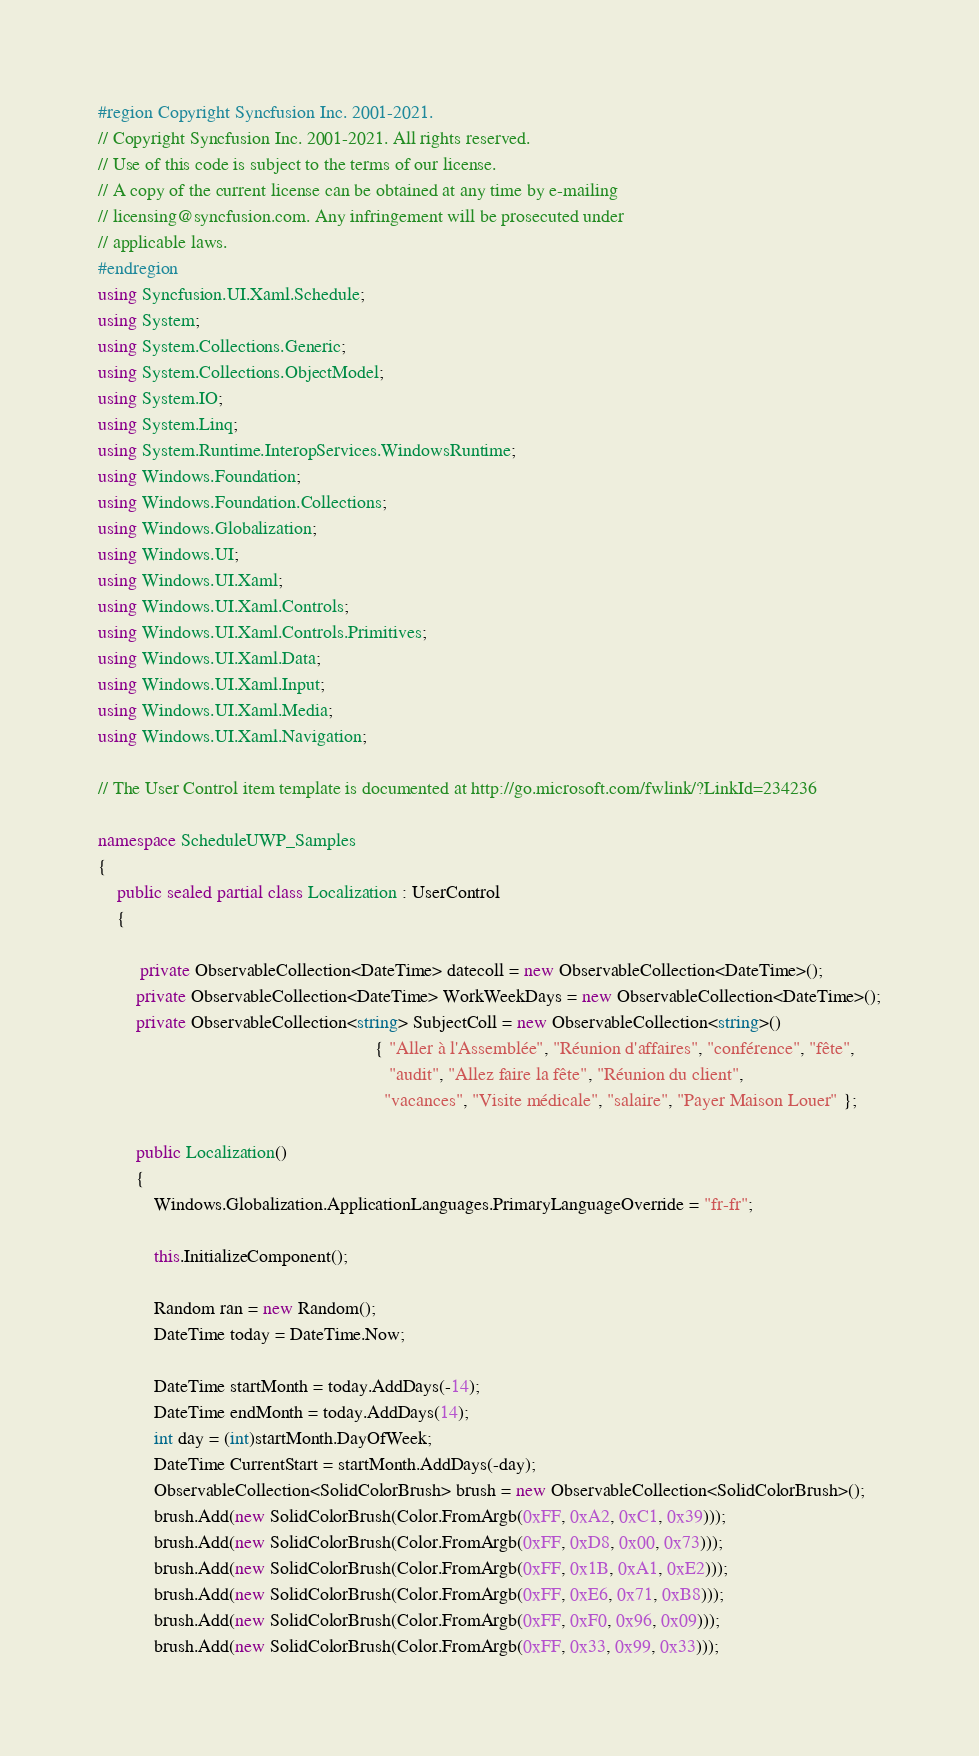<code> <loc_0><loc_0><loc_500><loc_500><_C#_>#region Copyright Syncfusion Inc. 2001-2021.
// Copyright Syncfusion Inc. 2001-2021. All rights reserved.
// Use of this code is subject to the terms of our license.
// A copy of the current license can be obtained at any time by e-mailing
// licensing@syncfusion.com. Any infringement will be prosecuted under
// applicable laws. 
#endregion
using Syncfusion.UI.Xaml.Schedule;
using System;
using System.Collections.Generic;
using System.Collections.ObjectModel;
using System.IO;
using System.Linq;
using System.Runtime.InteropServices.WindowsRuntime;
using Windows.Foundation;
using Windows.Foundation.Collections;
using Windows.Globalization;
using Windows.UI;
using Windows.UI.Xaml;
using Windows.UI.Xaml.Controls;
using Windows.UI.Xaml.Controls.Primitives;
using Windows.UI.Xaml.Data;
using Windows.UI.Xaml.Input;
using Windows.UI.Xaml.Media;
using Windows.UI.Xaml.Navigation;

// The User Control item template is documented at http://go.microsoft.com/fwlink/?LinkId=234236

namespace ScheduleUWP_Samples
{
    public sealed partial class Localization : UserControl
    {
        
         private ObservableCollection<DateTime> datecoll = new ObservableCollection<DateTime>();
        private ObservableCollection<DateTime> WorkWeekDays = new ObservableCollection<DateTime>();
        private ObservableCollection<string> SubjectColl = new ObservableCollection<string>()
                                                           { "Aller à l'Assemblée", "Réunion d'affaires", "conférence", "fête",
                                                              "audit", "Allez faire la fête", "Réunion du client",
                                                             "vacances", "Visite médicale", "salaire", "Payer Maison Louer" };

        public Localization()
        {
            Windows.Globalization.ApplicationLanguages.PrimaryLanguageOverride = "fr-fr";

            this.InitializeComponent();

            Random ran = new Random();
            DateTime today = DateTime.Now;

            DateTime startMonth = today.AddDays(-14);
            DateTime endMonth = today.AddDays(14);
            int day = (int)startMonth.DayOfWeek;
            DateTime CurrentStart = startMonth.AddDays(-day);
            ObservableCollection<SolidColorBrush> brush = new ObservableCollection<SolidColorBrush>();
            brush.Add(new SolidColorBrush(Color.FromArgb(0xFF, 0xA2, 0xC1, 0x39)));
            brush.Add(new SolidColorBrush(Color.FromArgb(0xFF, 0xD8, 0x00, 0x73)));
            brush.Add(new SolidColorBrush(Color.FromArgb(0xFF, 0x1B, 0xA1, 0xE2)));
            brush.Add(new SolidColorBrush(Color.FromArgb(0xFF, 0xE6, 0x71, 0xB8)));
            brush.Add(new SolidColorBrush(Color.FromArgb(0xFF, 0xF0, 0x96, 0x09)));
            brush.Add(new SolidColorBrush(Color.FromArgb(0xFF, 0x33, 0x99, 0x33)));</code> 